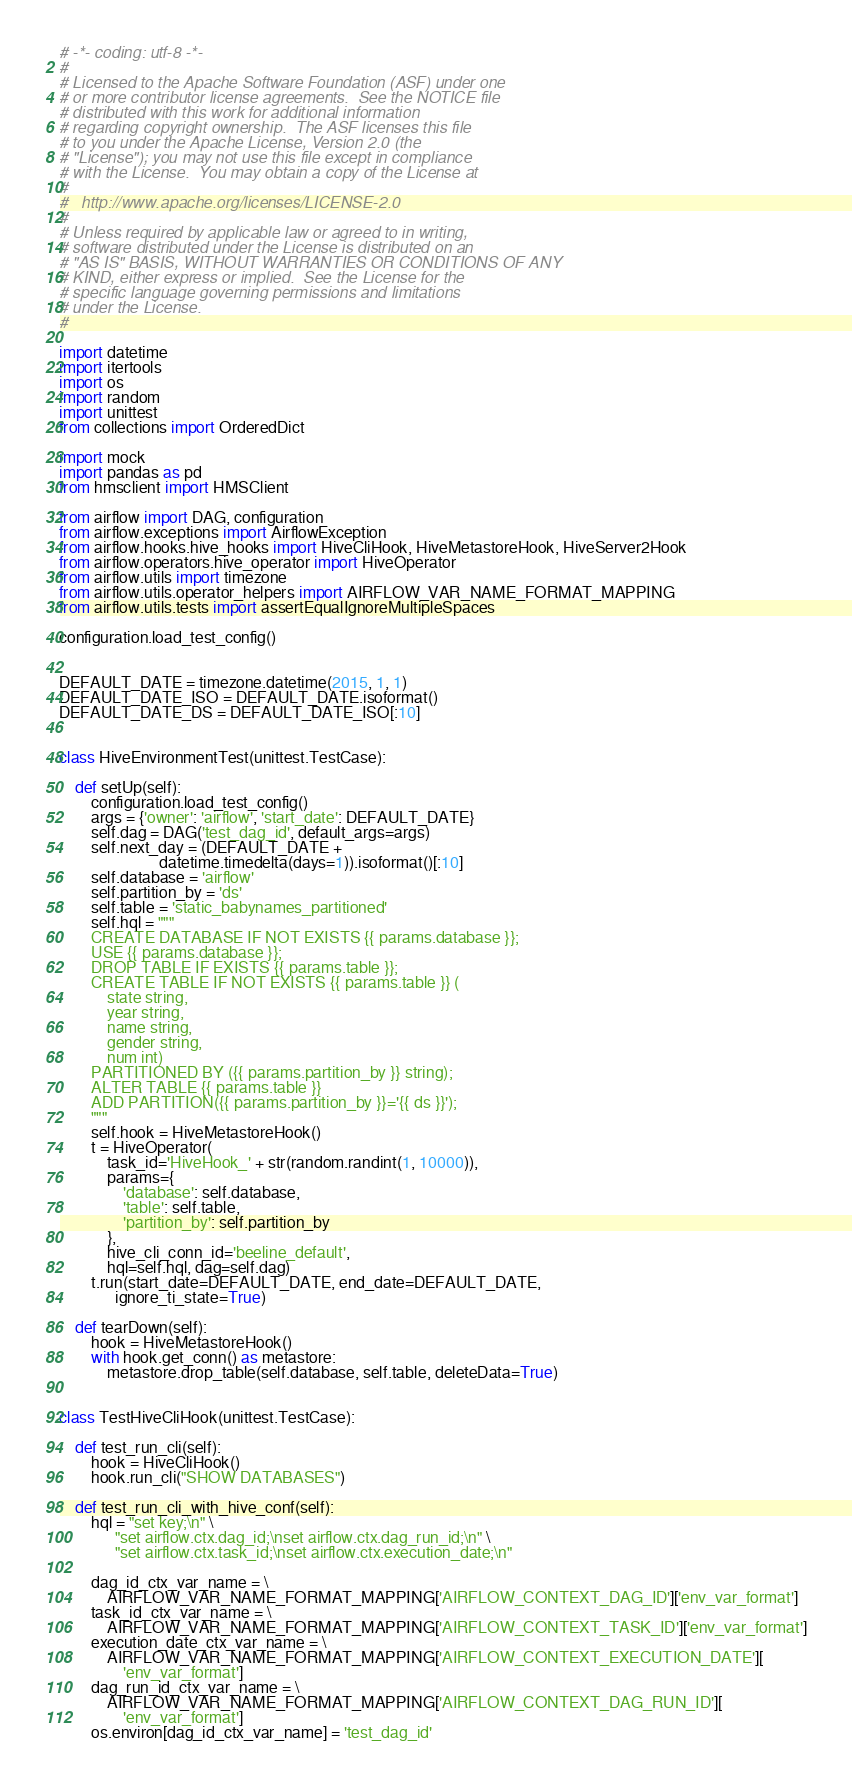<code> <loc_0><loc_0><loc_500><loc_500><_Python_># -*- coding: utf-8 -*-
#
# Licensed to the Apache Software Foundation (ASF) under one
# or more contributor license agreements.  See the NOTICE file
# distributed with this work for additional information
# regarding copyright ownership.  The ASF licenses this file
# to you under the Apache License, Version 2.0 (the
# "License"); you may not use this file except in compliance
# with the License.  You may obtain a copy of the License at
#
#   http://www.apache.org/licenses/LICENSE-2.0
#
# Unless required by applicable law or agreed to in writing,
# software distributed under the License is distributed on an
# "AS IS" BASIS, WITHOUT WARRANTIES OR CONDITIONS OF ANY
# KIND, either express or implied.  See the License for the
# specific language governing permissions and limitations
# under the License.
#

import datetime
import itertools
import os
import random
import unittest
from collections import OrderedDict

import mock
import pandas as pd
from hmsclient import HMSClient

from airflow import DAG, configuration
from airflow.exceptions import AirflowException
from airflow.hooks.hive_hooks import HiveCliHook, HiveMetastoreHook, HiveServer2Hook
from airflow.operators.hive_operator import HiveOperator
from airflow.utils import timezone
from airflow.utils.operator_helpers import AIRFLOW_VAR_NAME_FORMAT_MAPPING
from airflow.utils.tests import assertEqualIgnoreMultipleSpaces

configuration.load_test_config()


DEFAULT_DATE = timezone.datetime(2015, 1, 1)
DEFAULT_DATE_ISO = DEFAULT_DATE.isoformat()
DEFAULT_DATE_DS = DEFAULT_DATE_ISO[:10]


class HiveEnvironmentTest(unittest.TestCase):

    def setUp(self):
        configuration.load_test_config()
        args = {'owner': 'airflow', 'start_date': DEFAULT_DATE}
        self.dag = DAG('test_dag_id', default_args=args)
        self.next_day = (DEFAULT_DATE +
                         datetime.timedelta(days=1)).isoformat()[:10]
        self.database = 'airflow'
        self.partition_by = 'ds'
        self.table = 'static_babynames_partitioned'
        self.hql = """
        CREATE DATABASE IF NOT EXISTS {{ params.database }};
        USE {{ params.database }};
        DROP TABLE IF EXISTS {{ params.table }};
        CREATE TABLE IF NOT EXISTS {{ params.table }} (
            state string,
            year string,
            name string,
            gender string,
            num int)
        PARTITIONED BY ({{ params.partition_by }} string);
        ALTER TABLE {{ params.table }}
        ADD PARTITION({{ params.partition_by }}='{{ ds }}');
        """
        self.hook = HiveMetastoreHook()
        t = HiveOperator(
            task_id='HiveHook_' + str(random.randint(1, 10000)),
            params={
                'database': self.database,
                'table': self.table,
                'partition_by': self.partition_by
            },
            hive_cli_conn_id='beeline_default',
            hql=self.hql, dag=self.dag)
        t.run(start_date=DEFAULT_DATE, end_date=DEFAULT_DATE,
              ignore_ti_state=True)

    def tearDown(self):
        hook = HiveMetastoreHook()
        with hook.get_conn() as metastore:
            metastore.drop_table(self.database, self.table, deleteData=True)


class TestHiveCliHook(unittest.TestCase):

    def test_run_cli(self):
        hook = HiveCliHook()
        hook.run_cli("SHOW DATABASES")

    def test_run_cli_with_hive_conf(self):
        hql = "set key;\n" \
              "set airflow.ctx.dag_id;\nset airflow.ctx.dag_run_id;\n" \
              "set airflow.ctx.task_id;\nset airflow.ctx.execution_date;\n"

        dag_id_ctx_var_name = \
            AIRFLOW_VAR_NAME_FORMAT_MAPPING['AIRFLOW_CONTEXT_DAG_ID']['env_var_format']
        task_id_ctx_var_name = \
            AIRFLOW_VAR_NAME_FORMAT_MAPPING['AIRFLOW_CONTEXT_TASK_ID']['env_var_format']
        execution_date_ctx_var_name = \
            AIRFLOW_VAR_NAME_FORMAT_MAPPING['AIRFLOW_CONTEXT_EXECUTION_DATE'][
                'env_var_format']
        dag_run_id_ctx_var_name = \
            AIRFLOW_VAR_NAME_FORMAT_MAPPING['AIRFLOW_CONTEXT_DAG_RUN_ID'][
                'env_var_format']
        os.environ[dag_id_ctx_var_name] = 'test_dag_id'</code> 